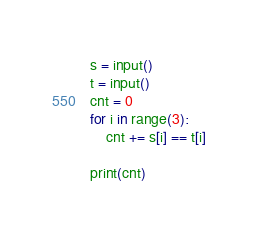Convert code to text. <code><loc_0><loc_0><loc_500><loc_500><_Python_>s = input()
t = input()
cnt = 0
for i in range(3):
    cnt += s[i] == t[i]

print(cnt)</code> 